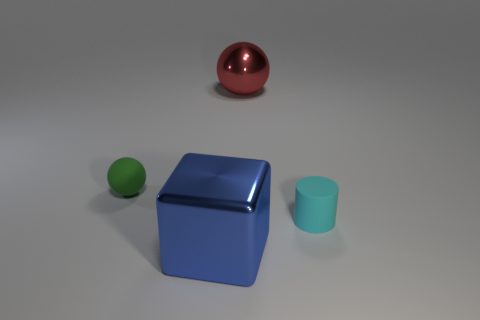Subtract 1 cylinders. How many cylinders are left? 0 Subtract all red balls. How many balls are left? 1 Add 2 big metallic objects. How many big metallic objects are left? 4 Add 4 small brown rubber things. How many small brown rubber things exist? 4 Add 1 tiny rubber spheres. How many objects exist? 5 Subtract 1 cyan cylinders. How many objects are left? 3 Subtract all blue spheres. Subtract all brown cylinders. How many spheres are left? 2 Subtract all cyan cubes. How many green cylinders are left? 0 Subtract all tiny green matte spheres. Subtract all tiny matte objects. How many objects are left? 1 